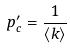<formula> <loc_0><loc_0><loc_500><loc_500>p _ { c } ^ { \prime } = \frac { 1 } { \langle k \rangle }</formula> 